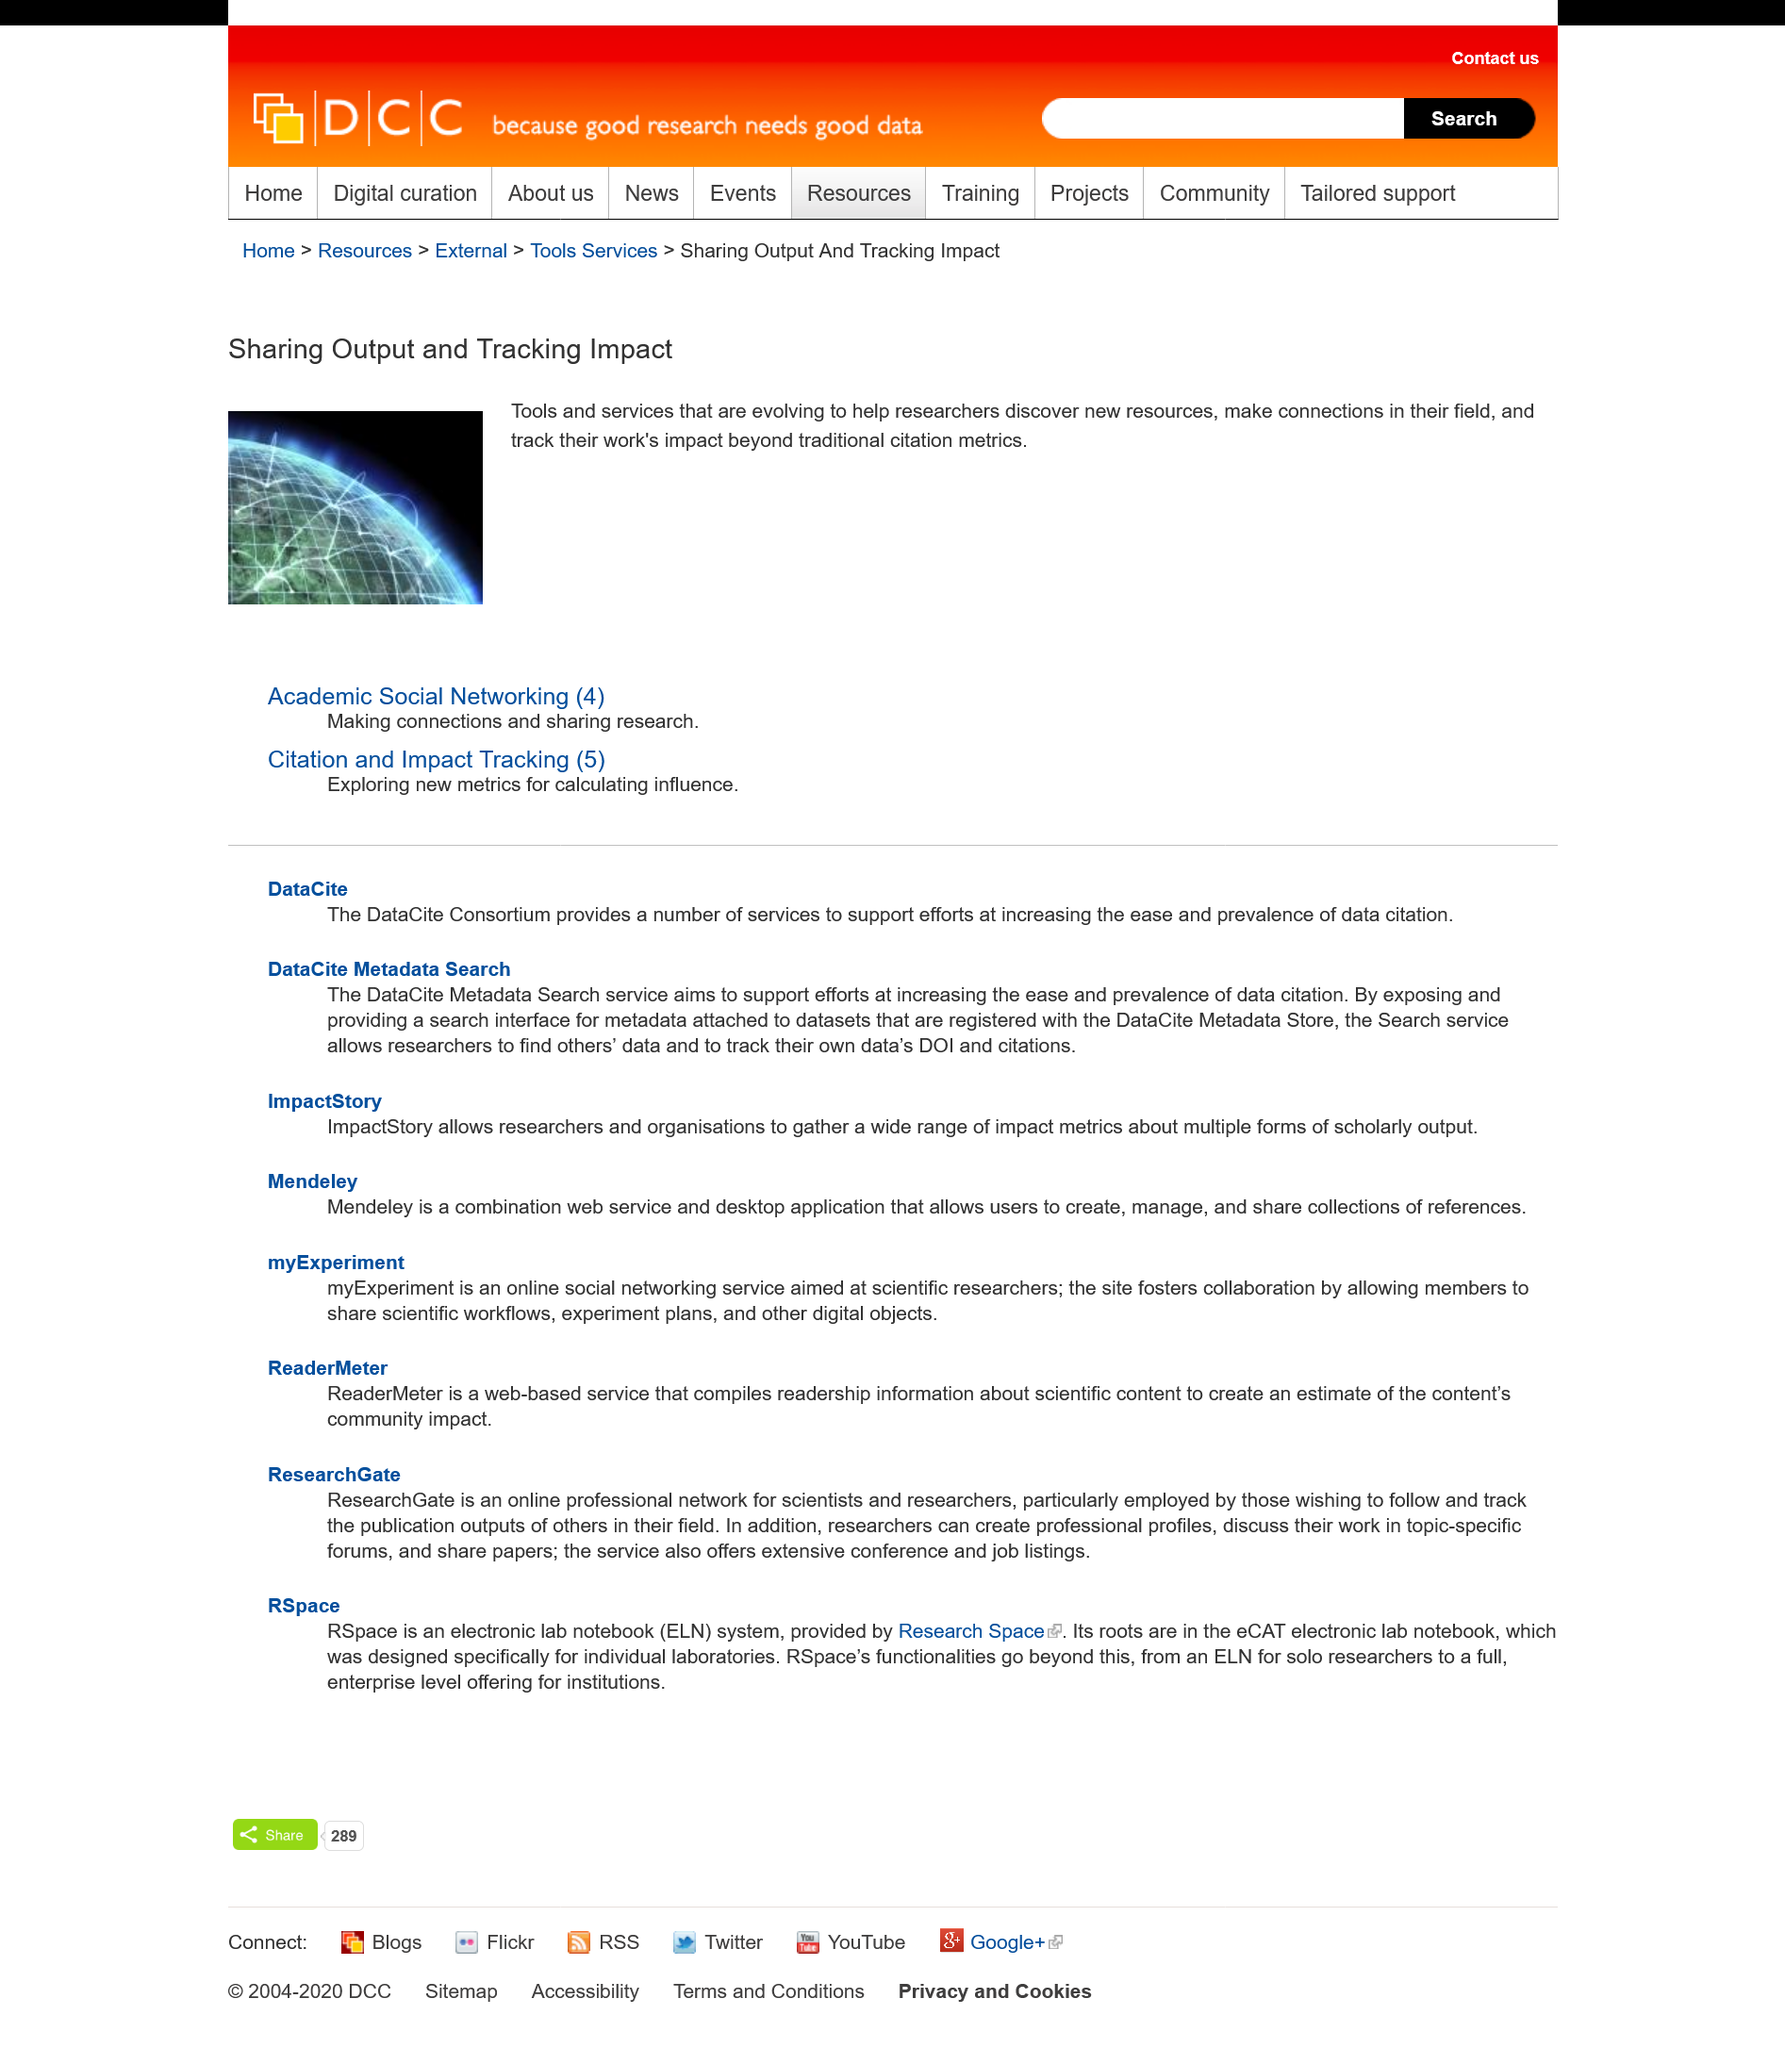Outline some significant characteristics in this image. ImpactStory enables researchers and organizations to gather a diverse range of impact metrics for multiple types of scholarly output. Research Space provides the RSpace system, which is supplied by [entity that provides RSpace system]. MyExperiment is an online social networking service that allows users to connect and share information with one another. The DataCite Consortium provides a number of services. The acronym ELN stands for electronic lab notebook, which is a digital platform used to record and manage scientific experiments and data. 